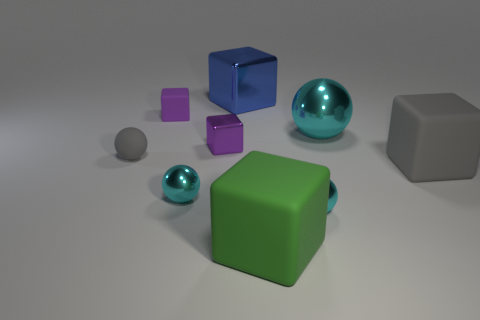Can you describe the colors of the cubes in the image? In the image, there are three cubes. Starting with the smallest, we have a vivid purple cube, then a medium-sized blue cube that exhibits some transparency, and finally a larger green cube with an opaque, matte finish. 